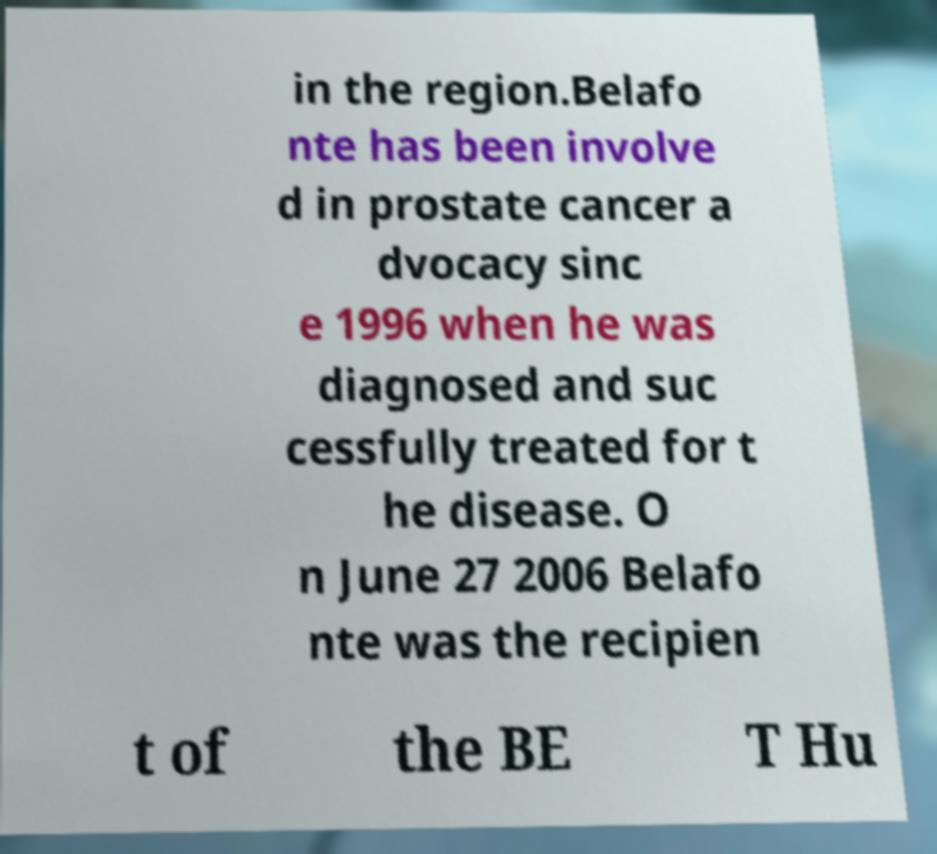Can you read and provide the text displayed in the image?This photo seems to have some interesting text. Can you extract and type it out for me? in the region.Belafo nte has been involve d in prostate cancer a dvocacy sinc e 1996 when he was diagnosed and suc cessfully treated for t he disease. O n June 27 2006 Belafo nte was the recipien t of the BE T Hu 